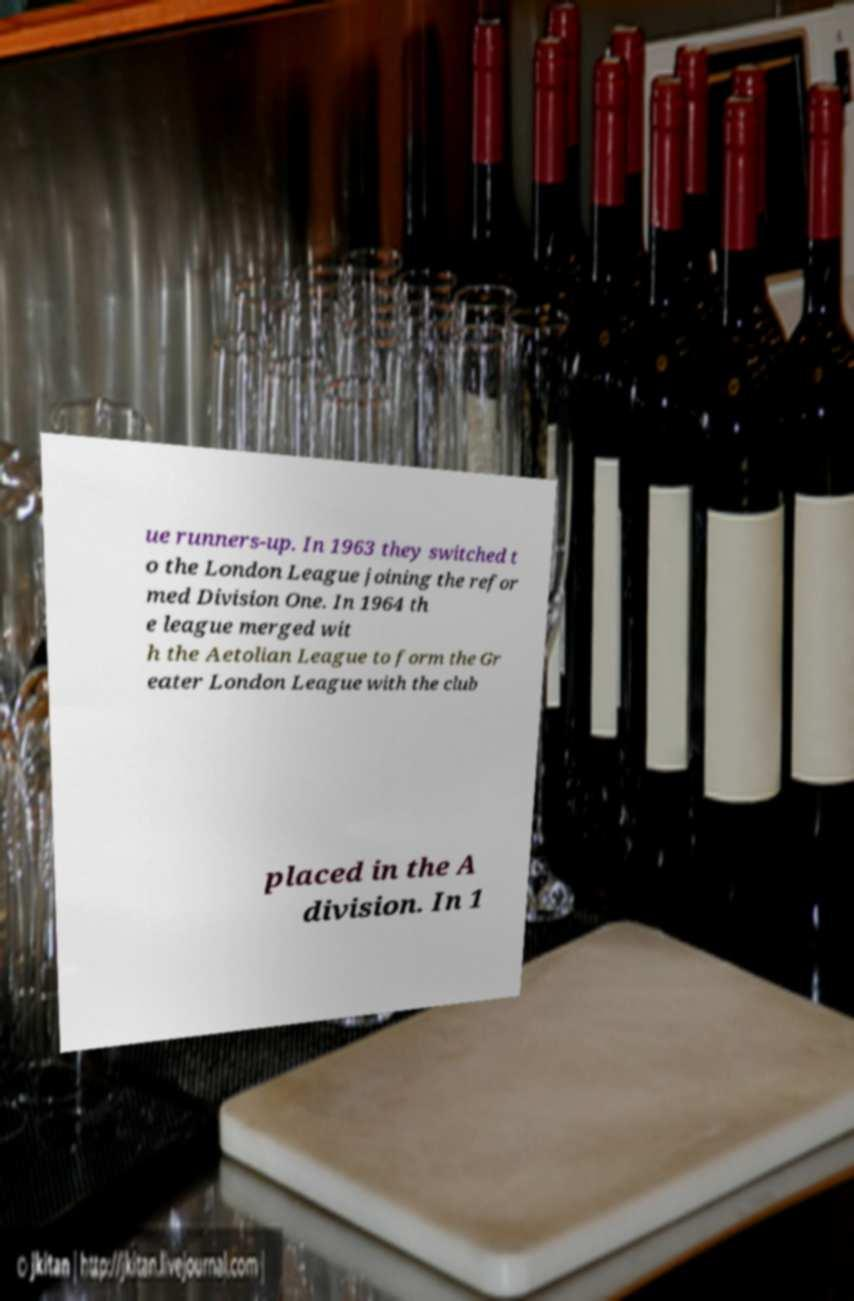Could you assist in decoding the text presented in this image and type it out clearly? ue runners-up. In 1963 they switched t o the London League joining the refor med Division One. In 1964 th e league merged wit h the Aetolian League to form the Gr eater London League with the club placed in the A division. In 1 